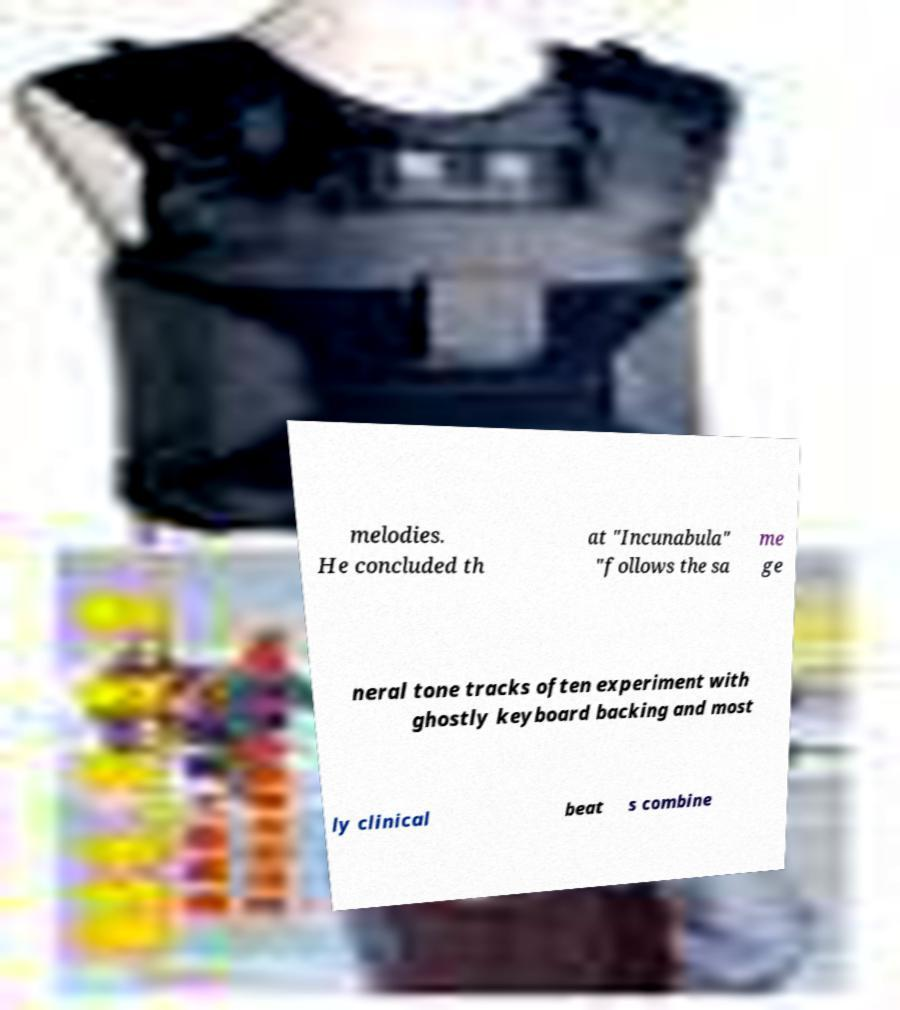For documentation purposes, I need the text within this image transcribed. Could you provide that? melodies. He concluded th at "Incunabula" "follows the sa me ge neral tone tracks often experiment with ghostly keyboard backing and most ly clinical beat s combine 